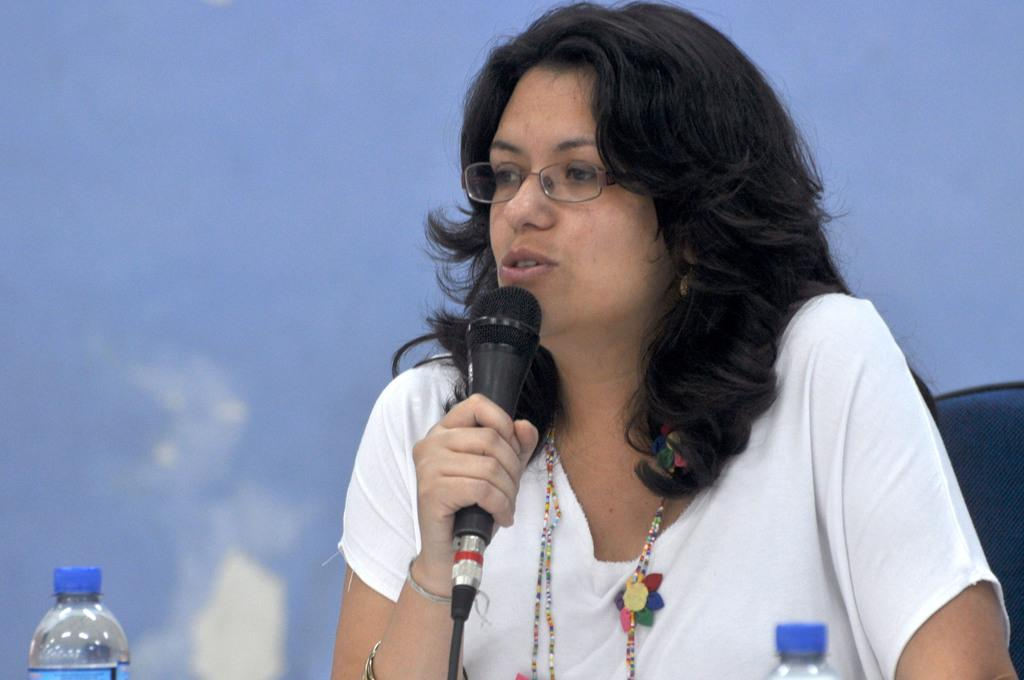Who is the main subject in the image? There is a woman in the image. What is the woman doing in the image? The woman is talking on a microphone. Can you describe the woman's appearance in the image? The woman is wearing spectacles. What else can be seen in the image besides the woman? There are bottles visible in the image. What type of egg is being stitched in the image? There is no egg or stitching present in the image. Can you hear the woman laughing while talking on the microphone in the image? The image is a still picture, so it does not capture any sounds, including laughter. 